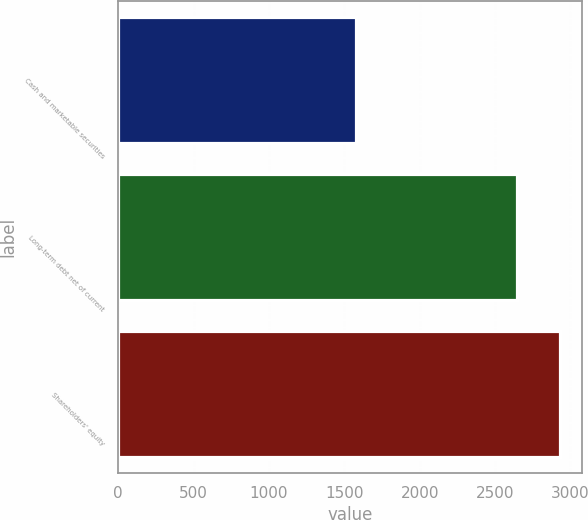<chart> <loc_0><loc_0><loc_500><loc_500><bar_chart><fcel>Cash and marketable securities<fcel>Long-term debt net of current<fcel>Shareholders' equity<nl><fcel>1580<fcel>2645<fcel>2931<nl></chart> 